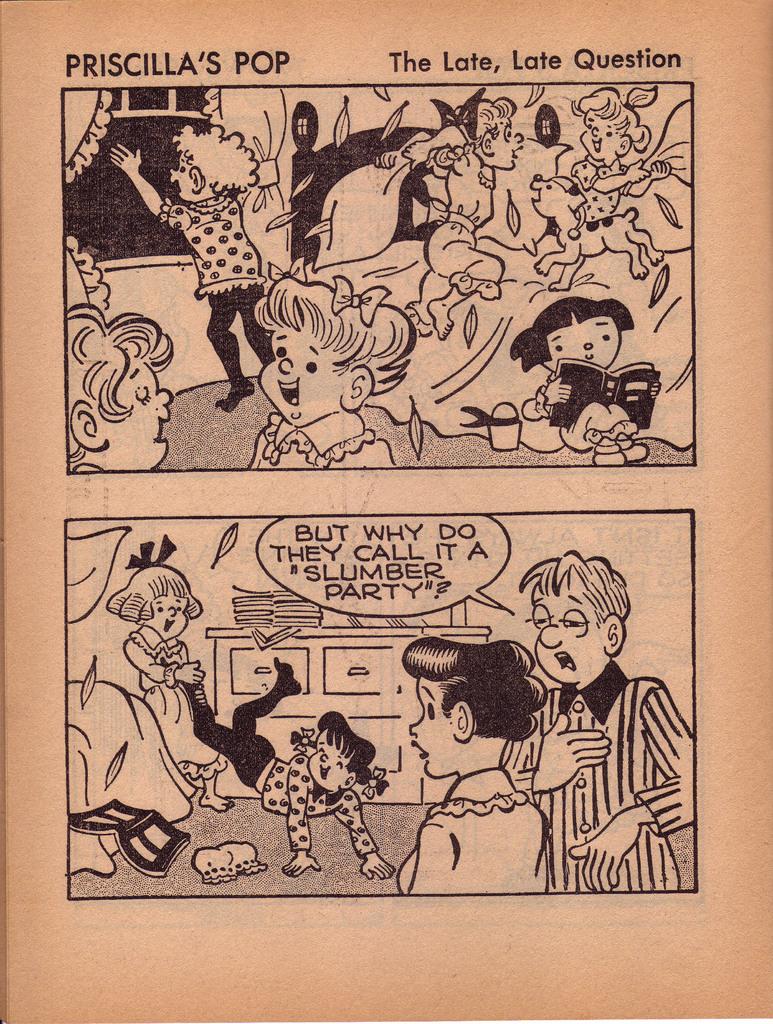What kind of party is dad asking about?
Your answer should be compact. Slumber party. What is the title of the comic?
Make the answer very short. Priscilla's pop the late, late question. 